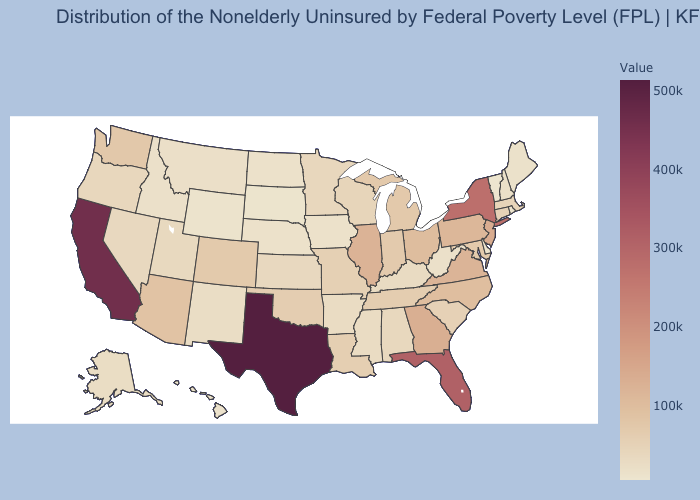Which states have the highest value in the USA?
Be succinct. Texas. Does California have the highest value in the West?
Answer briefly. Yes. Does Texas have the highest value in the USA?
Answer briefly. Yes. Does Tennessee have the highest value in the USA?
Keep it brief. No. Does Texas have the highest value in the USA?
Be succinct. Yes. Does Vermont have the lowest value in the USA?
Keep it brief. Yes. Does Virginia have the highest value in the South?
Answer briefly. No. Among the states that border Oregon , does Idaho have the lowest value?
Answer briefly. Yes. 